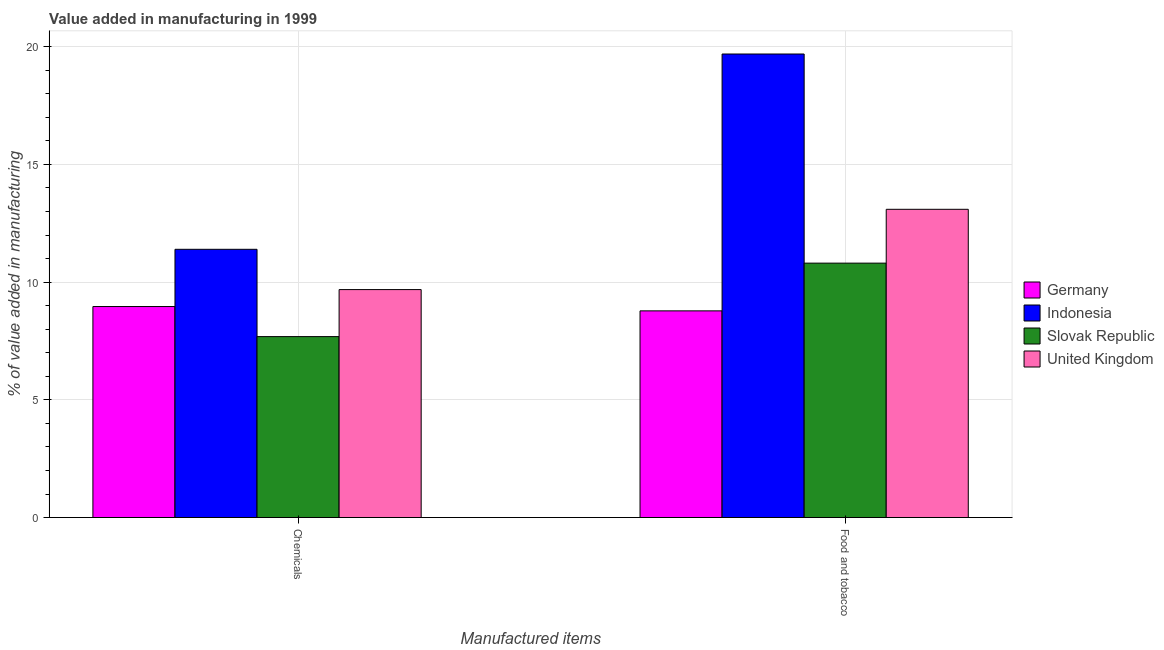Are the number of bars on each tick of the X-axis equal?
Keep it short and to the point. Yes. How many bars are there on the 1st tick from the right?
Your answer should be compact. 4. What is the label of the 2nd group of bars from the left?
Provide a succinct answer. Food and tobacco. What is the value added by  manufacturing chemicals in Germany?
Make the answer very short. 8.96. Across all countries, what is the maximum value added by  manufacturing chemicals?
Your answer should be compact. 11.39. Across all countries, what is the minimum value added by manufacturing food and tobacco?
Provide a short and direct response. 8.78. In which country was the value added by  manufacturing chemicals minimum?
Provide a succinct answer. Slovak Republic. What is the total value added by manufacturing food and tobacco in the graph?
Your answer should be compact. 52.36. What is the difference between the value added by manufacturing food and tobacco in Indonesia and that in United Kingdom?
Provide a succinct answer. 6.6. What is the difference between the value added by manufacturing food and tobacco in Indonesia and the value added by  manufacturing chemicals in United Kingdom?
Offer a terse response. 10.01. What is the average value added by  manufacturing chemicals per country?
Provide a succinct answer. 9.43. What is the difference between the value added by  manufacturing chemicals and value added by manufacturing food and tobacco in Indonesia?
Make the answer very short. -8.29. In how many countries, is the value added by manufacturing food and tobacco greater than 6 %?
Give a very brief answer. 4. What is the ratio of the value added by manufacturing food and tobacco in Slovak Republic to that in Germany?
Keep it short and to the point. 1.23. In how many countries, is the value added by  manufacturing chemicals greater than the average value added by  manufacturing chemicals taken over all countries?
Your answer should be very brief. 2. What does the 2nd bar from the right in Food and tobacco represents?
Offer a terse response. Slovak Republic. Are all the bars in the graph horizontal?
Your answer should be very brief. No. Are the values on the major ticks of Y-axis written in scientific E-notation?
Make the answer very short. No. Does the graph contain any zero values?
Offer a very short reply. No. Does the graph contain grids?
Provide a succinct answer. Yes. Where does the legend appear in the graph?
Provide a succinct answer. Center right. How are the legend labels stacked?
Provide a succinct answer. Vertical. What is the title of the graph?
Give a very brief answer. Value added in manufacturing in 1999. What is the label or title of the X-axis?
Ensure brevity in your answer.  Manufactured items. What is the label or title of the Y-axis?
Give a very brief answer. % of value added in manufacturing. What is the % of value added in manufacturing of Germany in Chemicals?
Keep it short and to the point. 8.96. What is the % of value added in manufacturing of Indonesia in Chemicals?
Provide a short and direct response. 11.39. What is the % of value added in manufacturing in Slovak Republic in Chemicals?
Provide a short and direct response. 7.69. What is the % of value added in manufacturing in United Kingdom in Chemicals?
Offer a terse response. 9.68. What is the % of value added in manufacturing in Germany in Food and tobacco?
Your answer should be compact. 8.78. What is the % of value added in manufacturing of Indonesia in Food and tobacco?
Provide a succinct answer. 19.69. What is the % of value added in manufacturing of Slovak Republic in Food and tobacco?
Provide a short and direct response. 10.81. What is the % of value added in manufacturing of United Kingdom in Food and tobacco?
Give a very brief answer. 13.09. Across all Manufactured items, what is the maximum % of value added in manufacturing in Germany?
Provide a succinct answer. 8.96. Across all Manufactured items, what is the maximum % of value added in manufacturing of Indonesia?
Your response must be concise. 19.69. Across all Manufactured items, what is the maximum % of value added in manufacturing of Slovak Republic?
Provide a short and direct response. 10.81. Across all Manufactured items, what is the maximum % of value added in manufacturing in United Kingdom?
Provide a succinct answer. 13.09. Across all Manufactured items, what is the minimum % of value added in manufacturing in Germany?
Make the answer very short. 8.78. Across all Manufactured items, what is the minimum % of value added in manufacturing in Indonesia?
Give a very brief answer. 11.39. Across all Manufactured items, what is the minimum % of value added in manufacturing in Slovak Republic?
Your response must be concise. 7.69. Across all Manufactured items, what is the minimum % of value added in manufacturing of United Kingdom?
Provide a succinct answer. 9.68. What is the total % of value added in manufacturing in Germany in the graph?
Your answer should be compact. 17.74. What is the total % of value added in manufacturing of Indonesia in the graph?
Your answer should be compact. 31.08. What is the total % of value added in manufacturing of Slovak Republic in the graph?
Your answer should be very brief. 18.49. What is the total % of value added in manufacturing of United Kingdom in the graph?
Your answer should be compact. 22.77. What is the difference between the % of value added in manufacturing of Germany in Chemicals and that in Food and tobacco?
Provide a short and direct response. 0.18. What is the difference between the % of value added in manufacturing in Indonesia in Chemicals and that in Food and tobacco?
Ensure brevity in your answer.  -8.29. What is the difference between the % of value added in manufacturing in Slovak Republic in Chemicals and that in Food and tobacco?
Your answer should be very brief. -3.12. What is the difference between the % of value added in manufacturing in United Kingdom in Chemicals and that in Food and tobacco?
Give a very brief answer. -3.41. What is the difference between the % of value added in manufacturing in Germany in Chemicals and the % of value added in manufacturing in Indonesia in Food and tobacco?
Make the answer very short. -10.73. What is the difference between the % of value added in manufacturing in Germany in Chemicals and the % of value added in manufacturing in Slovak Republic in Food and tobacco?
Give a very brief answer. -1.84. What is the difference between the % of value added in manufacturing in Germany in Chemicals and the % of value added in manufacturing in United Kingdom in Food and tobacco?
Offer a terse response. -4.13. What is the difference between the % of value added in manufacturing in Indonesia in Chemicals and the % of value added in manufacturing in Slovak Republic in Food and tobacco?
Give a very brief answer. 0.59. What is the difference between the % of value added in manufacturing in Indonesia in Chemicals and the % of value added in manufacturing in United Kingdom in Food and tobacco?
Offer a terse response. -1.7. What is the difference between the % of value added in manufacturing of Slovak Republic in Chemicals and the % of value added in manufacturing of United Kingdom in Food and tobacco?
Ensure brevity in your answer.  -5.41. What is the average % of value added in manufacturing in Germany per Manufactured items?
Keep it short and to the point. 8.87. What is the average % of value added in manufacturing in Indonesia per Manufactured items?
Ensure brevity in your answer.  15.54. What is the average % of value added in manufacturing of Slovak Republic per Manufactured items?
Provide a succinct answer. 9.25. What is the average % of value added in manufacturing of United Kingdom per Manufactured items?
Offer a very short reply. 11.39. What is the difference between the % of value added in manufacturing in Germany and % of value added in manufacturing in Indonesia in Chemicals?
Your answer should be compact. -2.43. What is the difference between the % of value added in manufacturing in Germany and % of value added in manufacturing in Slovak Republic in Chemicals?
Offer a very short reply. 1.28. What is the difference between the % of value added in manufacturing in Germany and % of value added in manufacturing in United Kingdom in Chemicals?
Your response must be concise. -0.72. What is the difference between the % of value added in manufacturing in Indonesia and % of value added in manufacturing in Slovak Republic in Chemicals?
Your answer should be compact. 3.71. What is the difference between the % of value added in manufacturing of Indonesia and % of value added in manufacturing of United Kingdom in Chemicals?
Your answer should be compact. 1.71. What is the difference between the % of value added in manufacturing in Slovak Republic and % of value added in manufacturing in United Kingdom in Chemicals?
Ensure brevity in your answer.  -2. What is the difference between the % of value added in manufacturing of Germany and % of value added in manufacturing of Indonesia in Food and tobacco?
Offer a very short reply. -10.91. What is the difference between the % of value added in manufacturing of Germany and % of value added in manufacturing of Slovak Republic in Food and tobacco?
Ensure brevity in your answer.  -2.03. What is the difference between the % of value added in manufacturing in Germany and % of value added in manufacturing in United Kingdom in Food and tobacco?
Ensure brevity in your answer.  -4.31. What is the difference between the % of value added in manufacturing in Indonesia and % of value added in manufacturing in Slovak Republic in Food and tobacco?
Your answer should be compact. 8.88. What is the difference between the % of value added in manufacturing of Indonesia and % of value added in manufacturing of United Kingdom in Food and tobacco?
Your answer should be very brief. 6.6. What is the difference between the % of value added in manufacturing of Slovak Republic and % of value added in manufacturing of United Kingdom in Food and tobacco?
Offer a very short reply. -2.29. What is the ratio of the % of value added in manufacturing of Germany in Chemicals to that in Food and tobacco?
Provide a succinct answer. 1.02. What is the ratio of the % of value added in manufacturing of Indonesia in Chemicals to that in Food and tobacco?
Ensure brevity in your answer.  0.58. What is the ratio of the % of value added in manufacturing of Slovak Republic in Chemicals to that in Food and tobacco?
Give a very brief answer. 0.71. What is the ratio of the % of value added in manufacturing of United Kingdom in Chemicals to that in Food and tobacco?
Make the answer very short. 0.74. What is the difference between the highest and the second highest % of value added in manufacturing in Germany?
Keep it short and to the point. 0.18. What is the difference between the highest and the second highest % of value added in manufacturing of Indonesia?
Offer a very short reply. 8.29. What is the difference between the highest and the second highest % of value added in manufacturing of Slovak Republic?
Offer a very short reply. 3.12. What is the difference between the highest and the second highest % of value added in manufacturing in United Kingdom?
Provide a succinct answer. 3.41. What is the difference between the highest and the lowest % of value added in manufacturing in Germany?
Give a very brief answer. 0.18. What is the difference between the highest and the lowest % of value added in manufacturing of Indonesia?
Your response must be concise. 8.29. What is the difference between the highest and the lowest % of value added in manufacturing in Slovak Republic?
Your answer should be very brief. 3.12. What is the difference between the highest and the lowest % of value added in manufacturing of United Kingdom?
Your answer should be compact. 3.41. 